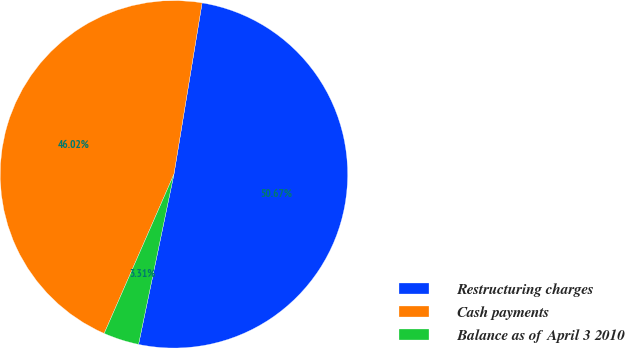Convert chart to OTSL. <chart><loc_0><loc_0><loc_500><loc_500><pie_chart><fcel>Restructuring charges<fcel>Cash payments<fcel>Balance as of April 3 2010<nl><fcel>50.67%<fcel>46.02%<fcel>3.31%<nl></chart> 